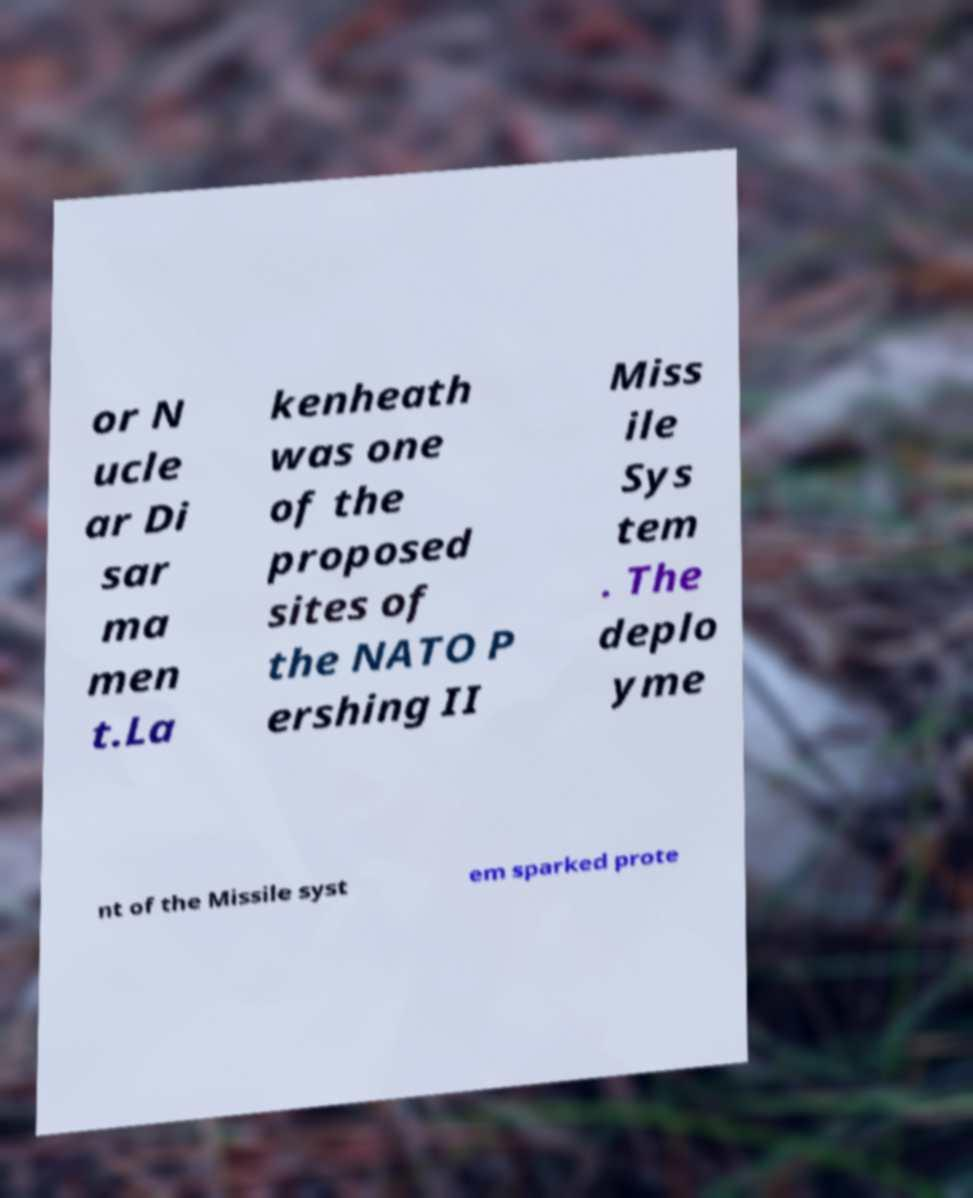I need the written content from this picture converted into text. Can you do that? or N ucle ar Di sar ma men t.La kenheath was one of the proposed sites of the NATO P ershing II Miss ile Sys tem . The deplo yme nt of the Missile syst em sparked prote 